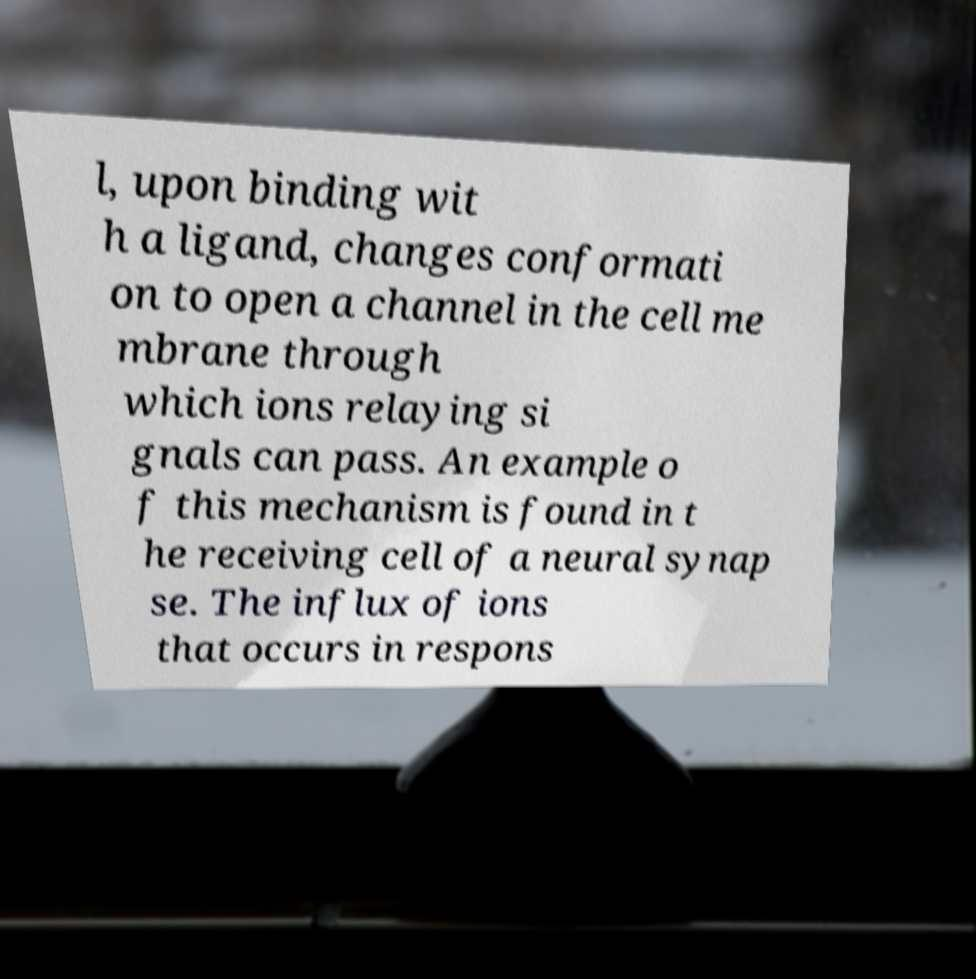Please read and relay the text visible in this image. What does it say? l, upon binding wit h a ligand, changes conformati on to open a channel in the cell me mbrane through which ions relaying si gnals can pass. An example o f this mechanism is found in t he receiving cell of a neural synap se. The influx of ions that occurs in respons 